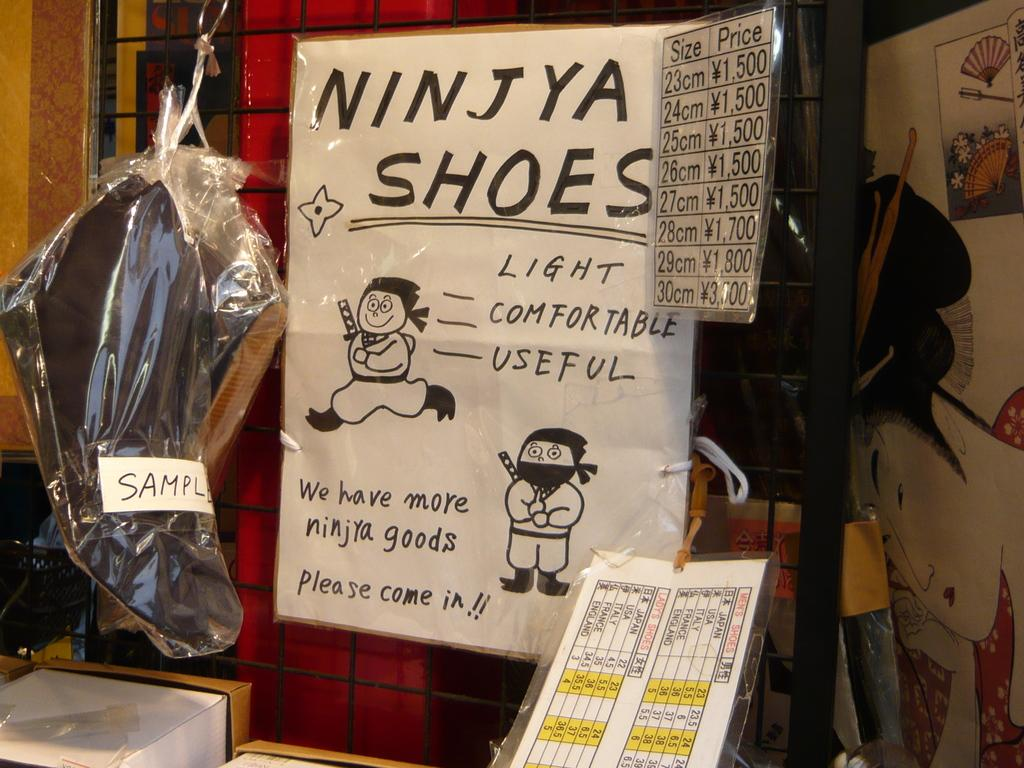<image>
Share a concise interpretation of the image provided. A handmade ad for Ninjya Shoes is posted next to a price list. 